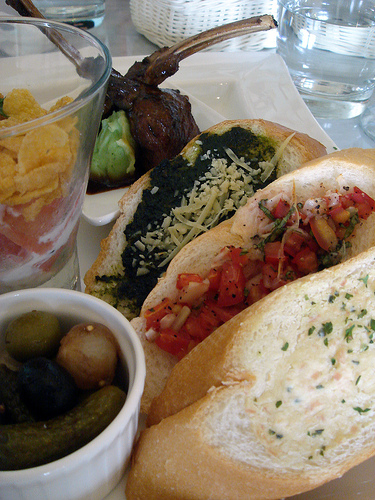<image>
Can you confirm if the glass is on the table? Yes. Looking at the image, I can see the glass is positioned on top of the table, with the table providing support. 